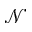Convert formula to latex. <formula><loc_0><loc_0><loc_500><loc_500>\mathcal { N }</formula> 